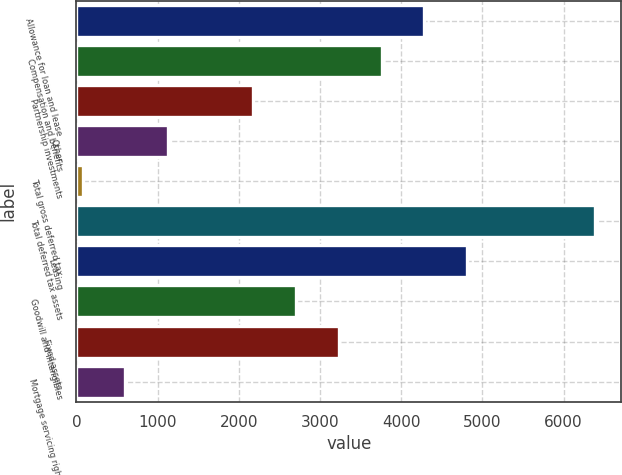<chart> <loc_0><loc_0><loc_500><loc_500><bar_chart><fcel>Allowance for loan and lease<fcel>Compensation and benefits<fcel>Partnership investments<fcel>Other<fcel>Total gross deferred tax<fcel>Total deferred tax assets<fcel>Leasing<fcel>Goodwill and intangibles<fcel>Fixed assets<fcel>Mortgage servicing rights<nl><fcel>4286.2<fcel>3759.8<fcel>2180.6<fcel>1127.8<fcel>75<fcel>6391.8<fcel>4812.6<fcel>2707<fcel>3233.4<fcel>601.4<nl></chart> 